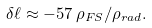Convert formula to latex. <formula><loc_0><loc_0><loc_500><loc_500>\delta \ell \approx - 5 7 \, \rho _ { F S } / \rho _ { r a d } .</formula> 